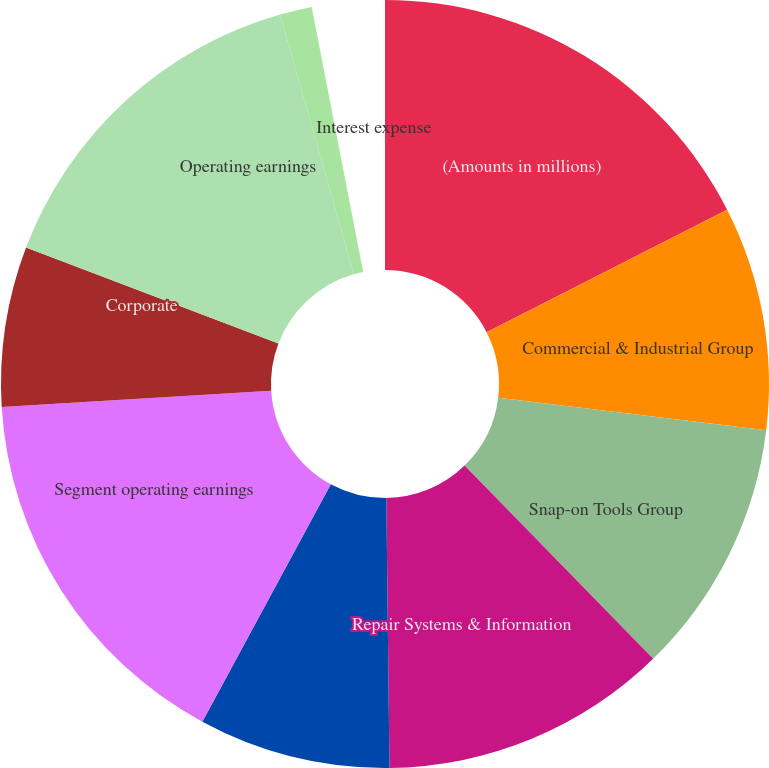Convert chart to OTSL. <chart><loc_0><loc_0><loc_500><loc_500><pie_chart><fcel>(Amounts in millions)<fcel>Commercial & Industrial Group<fcel>Snap-on Tools Group<fcel>Repair Systems & Information<fcel>Financial Services<fcel>Segment operating earnings<fcel>Corporate<fcel>Operating earnings<fcel>Interest expense<fcel>Other income (expense) - net<nl><fcel>18.05%<fcel>9.72%<fcel>11.11%<fcel>12.5%<fcel>8.33%<fcel>16.66%<fcel>6.95%<fcel>15.28%<fcel>1.39%<fcel>0.0%<nl></chart> 